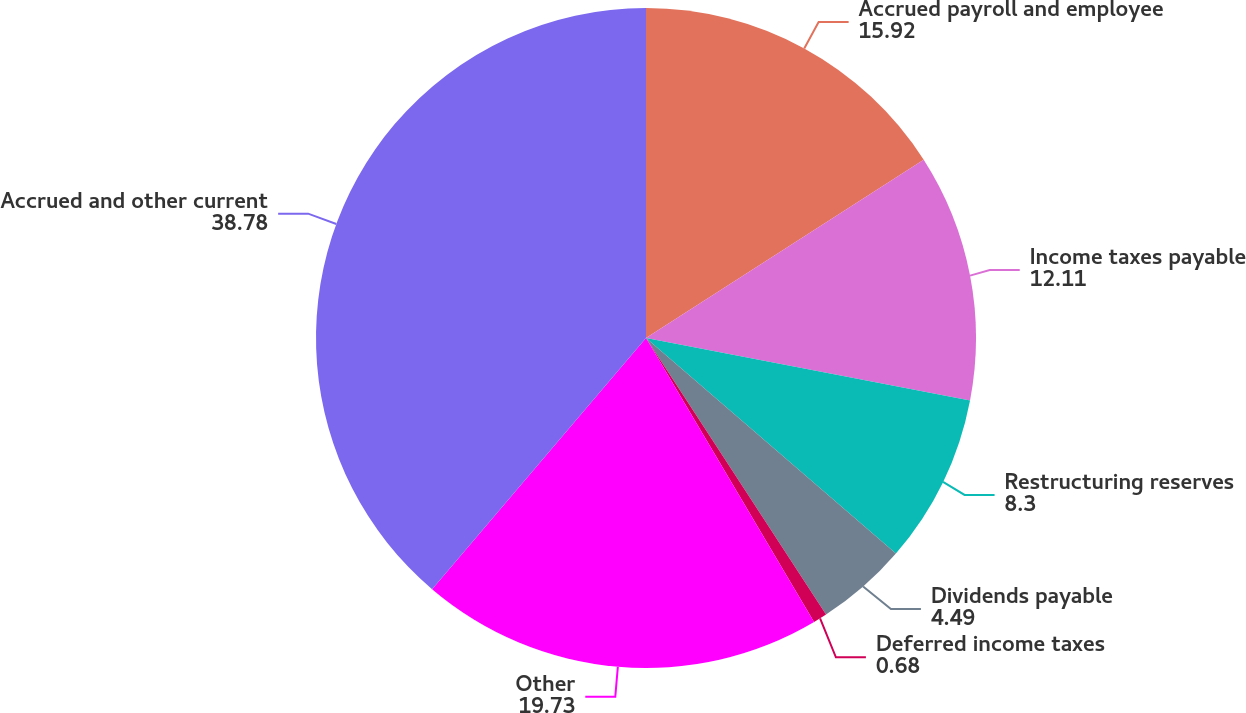<chart> <loc_0><loc_0><loc_500><loc_500><pie_chart><fcel>Accrued payroll and employee<fcel>Income taxes payable<fcel>Restructuring reserves<fcel>Dividends payable<fcel>Deferred income taxes<fcel>Other<fcel>Accrued and other current<nl><fcel>15.92%<fcel>12.11%<fcel>8.3%<fcel>4.49%<fcel>0.68%<fcel>19.73%<fcel>38.78%<nl></chart> 